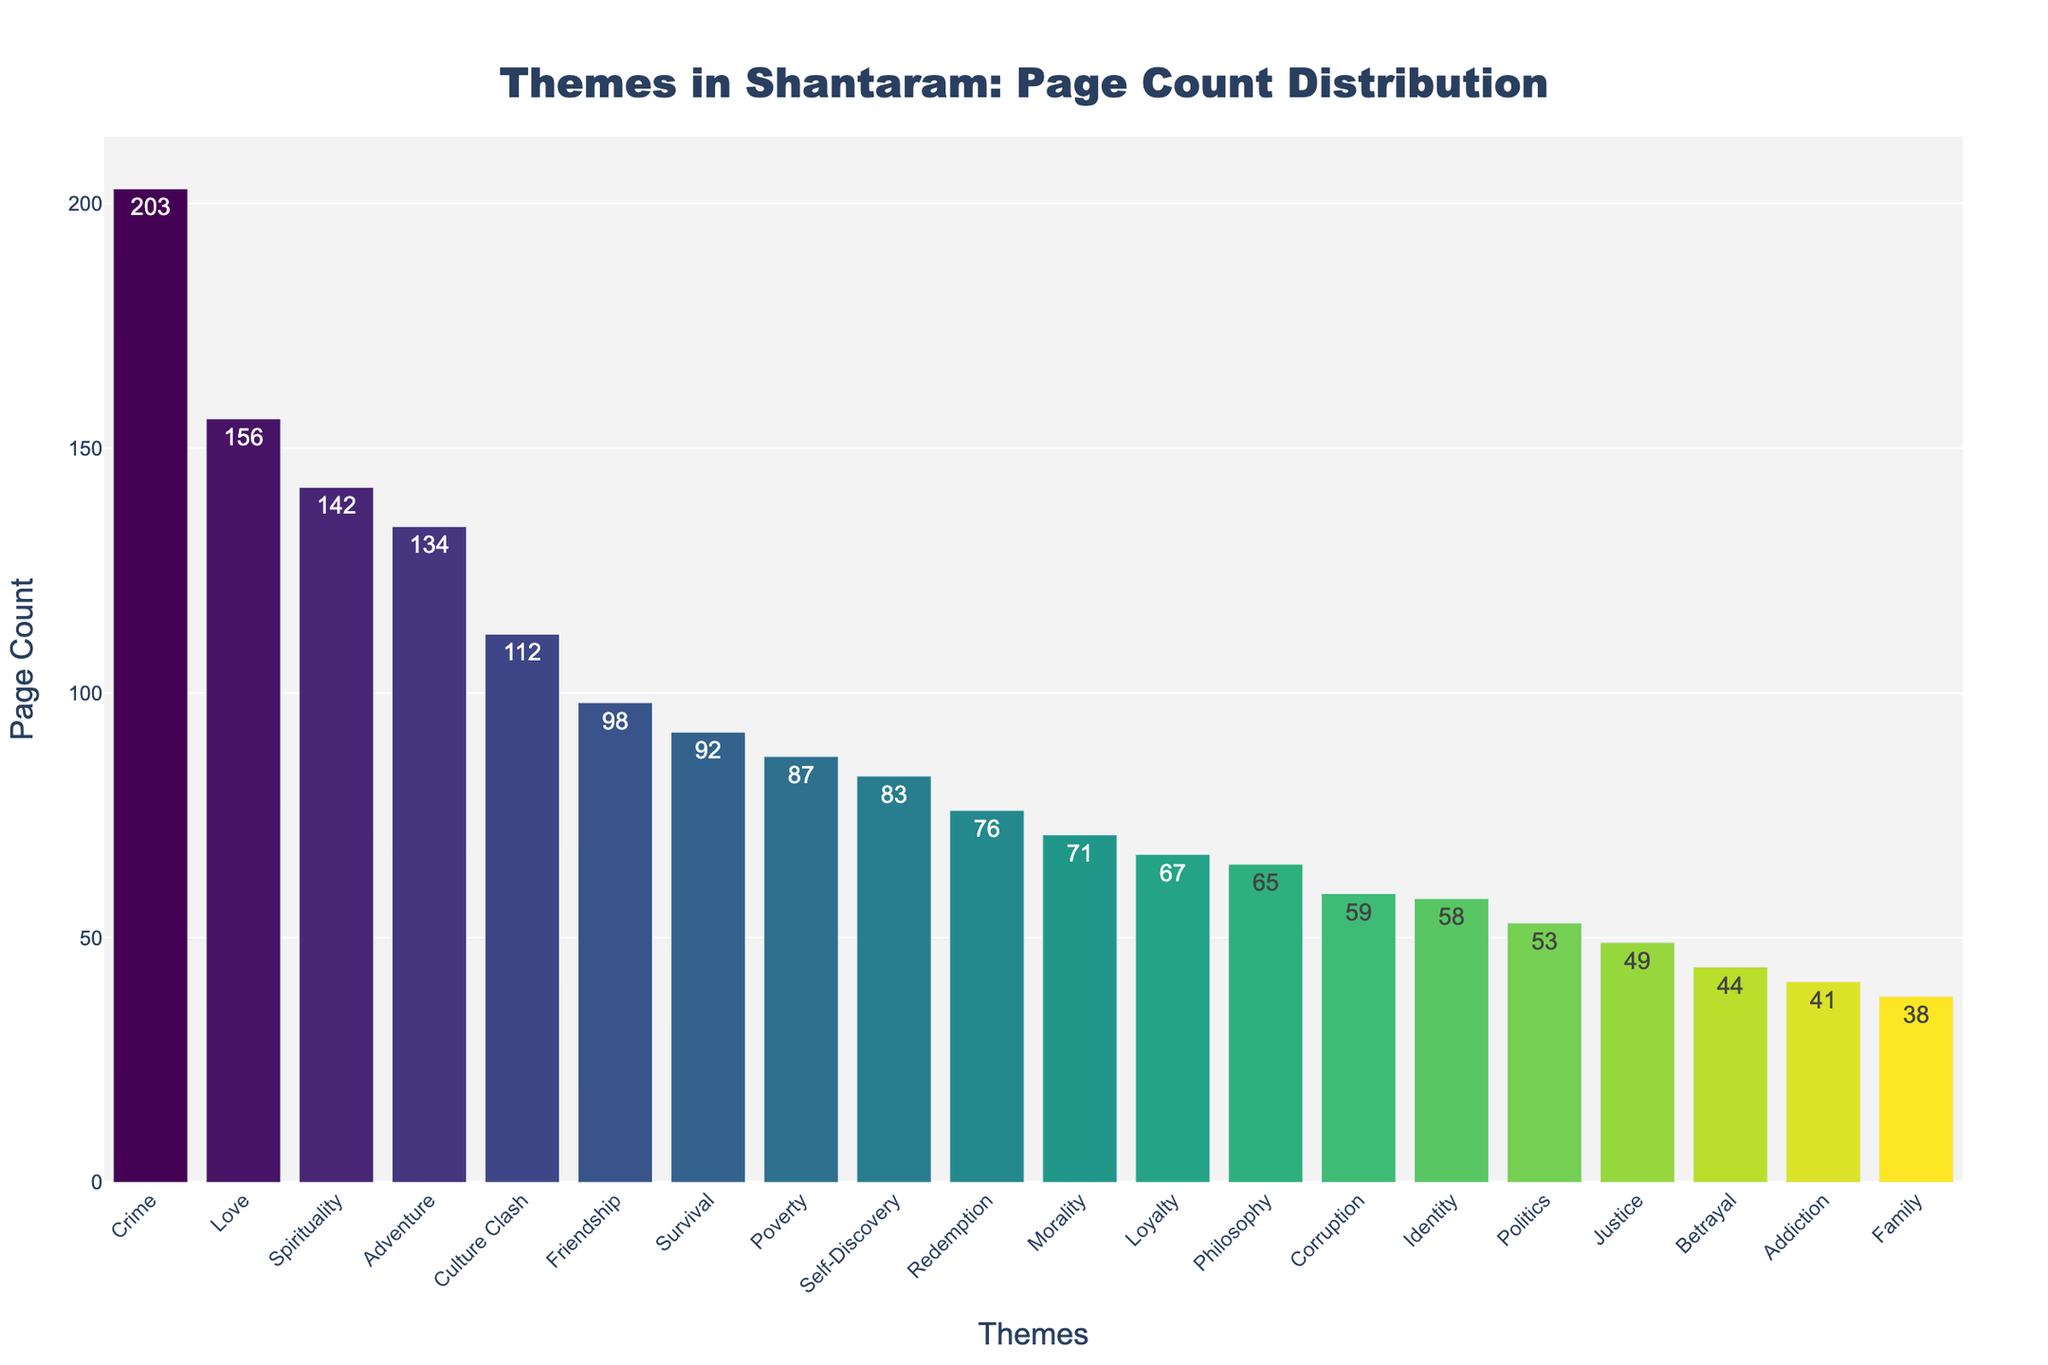Which theme has the highest page count? The theme with the highest page count can be identified from the bar that extends the furthest to the right in the chart, which is "Crime".
Answer: Crime What is the total page count for the themes "Love" and "Friendship"? To find the total page count for "Love" and "Friendship", sum the page counts of these two themes. "Love" has 156 pages and "Friendship" has 98 pages. 156 + 98 = 254
Answer: 254 Which theme has a lower page count, "Philosophy" or "Morality"? Compare the bar lengths for "Philosophy" and "Morality". The bar for "Philosophy" is shorter than the bar for "Morality".
Answer: Philosophy What is the difference between the page counts of "Survival" and "Politics"? Subtract the page count of "Politics" from that of "Survival". "Survival" has 92 pages and "Politics" has 53 pages. 92 - 53 = 39
Answer: 39 Which theme has almost half of the page count compared to "Crime"? To find which theme is approximately half of the page count of "Crime" (which is 203), look for a theme with around 101 or 102 pages. "Culture Clash" with 112 pages is close to half of "Crime".
Answer: Culture Clash What is the average page count for the themes "Adventure", "Identity", and "Corruption"? First sum the pages for "Adventure" (134), "Identity" (58), and "Corruption" (59). The total is 134 + 58 + 59 = 251. Divide by three to find the average: 251 / 3 ≈ 83.67
Answer: 83.67 Which theme has the shortest bar (least page count) in the figure? Identify the shortest bar in the chart, which corresponds to the theme "Family".
Answer: Family How many themes have a page count greater than 100? Count the number of bars representing themes where the page count exceeds 100. These are "Love", "Crime", "Spirituality", "Adventure", and "Culture Clash".
Answer: 5 